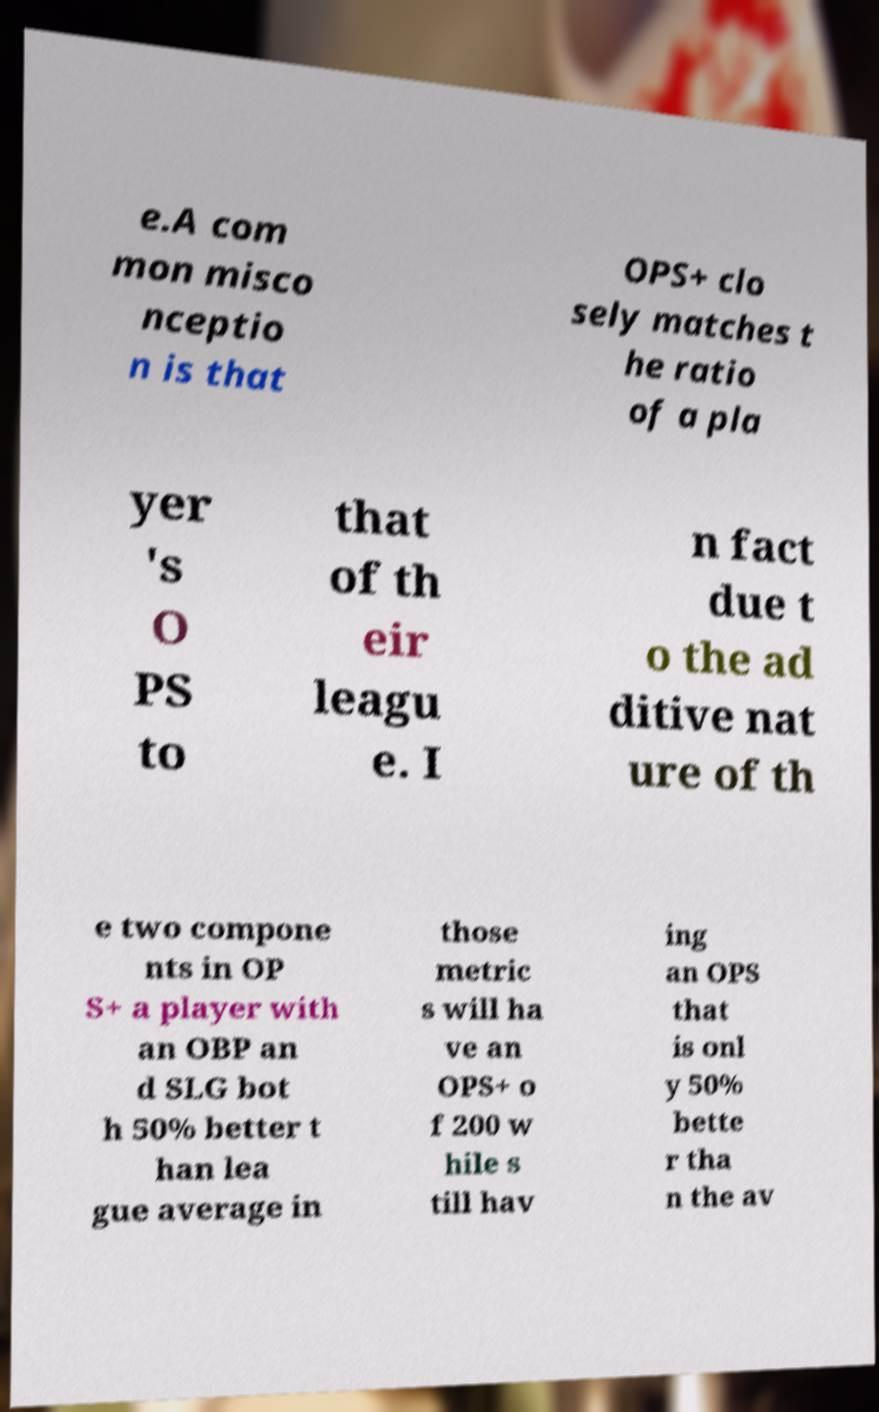There's text embedded in this image that I need extracted. Can you transcribe it verbatim? e.A com mon misco nceptio n is that OPS+ clo sely matches t he ratio of a pla yer 's O PS to that of th eir leagu e. I n fact due t o the ad ditive nat ure of th e two compone nts in OP S+ a player with an OBP an d SLG bot h 50% better t han lea gue average in those metric s will ha ve an OPS+ o f 200 w hile s till hav ing an OPS that is onl y 50% bette r tha n the av 